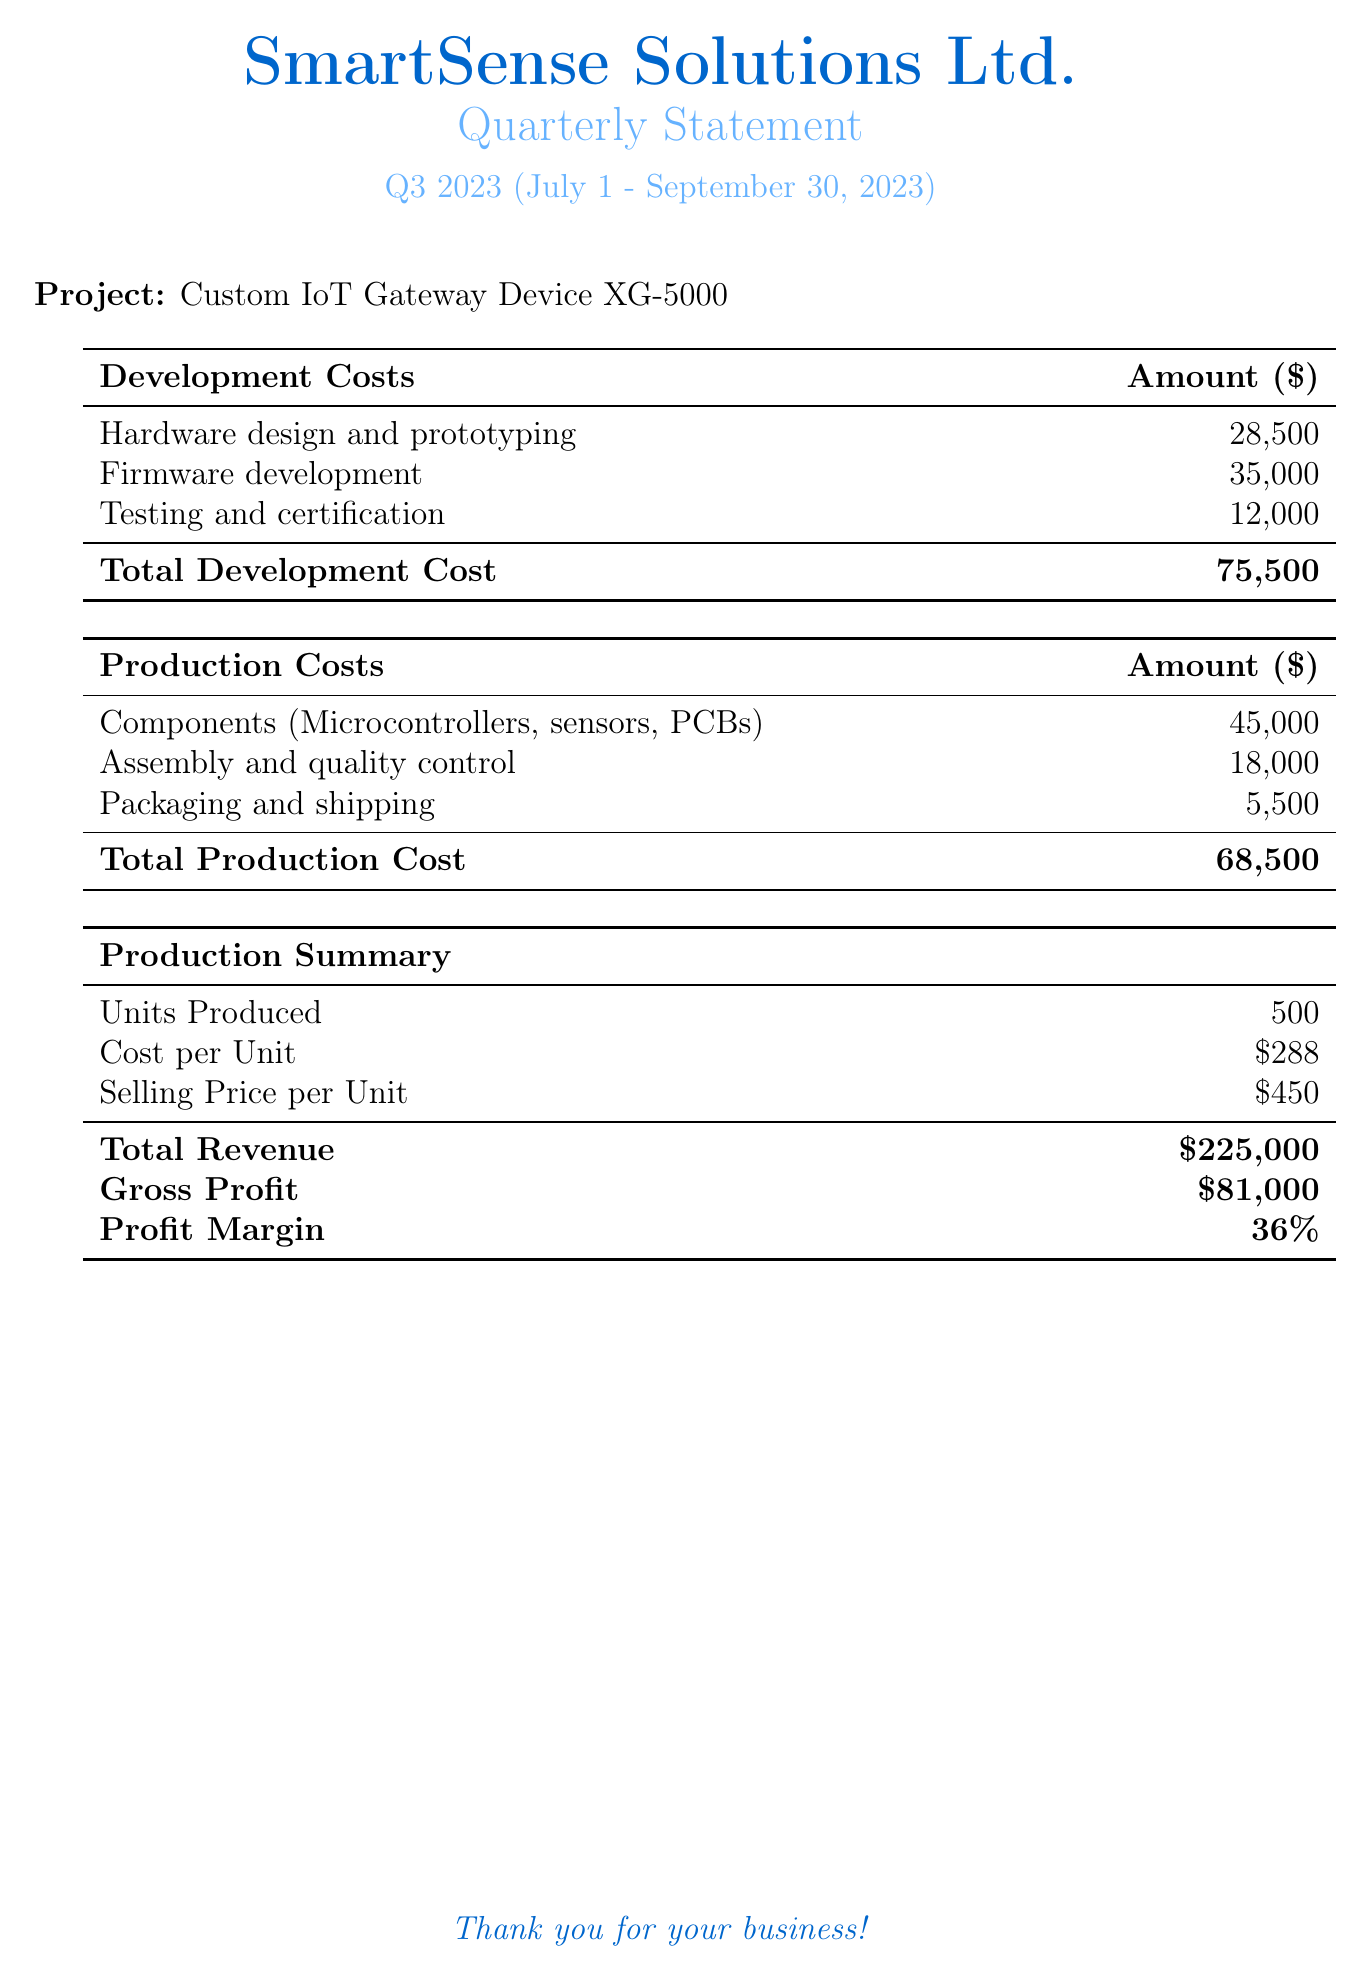What is the total development cost? The total development cost is listed in the document, which is the sum of all development costs.
Answer: 75,500 What is the total production cost? The total production cost is stated at the bottom of the production costs table in the document.
Answer: 68,500 How many units were produced? The number of units produced is mentioned in the production summary section of the document.
Answer: 500 What is the selling price per unit? The selling price per unit is provided in the production summary section of the document.
Answer: 450 What is the gross profit? The gross profit can be found in the production summary section, calculated by subtracting total costs from total revenue.
Answer: 81,000 What are the components included in the production costs? The document lists the components within the production costs section.
Answer: Microcontrollers, sensors, PCBs What is the profit margin? The profit margin is given in the production summary section of the document as a percentage.
Answer: 36% What is the period of the quarterly statement? The document specifies the period covered by the quarterly statement.
Answer: July 1 - September 30, 2023 What is the project name? The document lists the project name at the beginning in the project section.
Answer: Custom IoT Gateway Device XG-5000 What is the total revenue? The total revenue is calculated based on the selling price and units produced, shown in the production summary section.
Answer: 225,000 